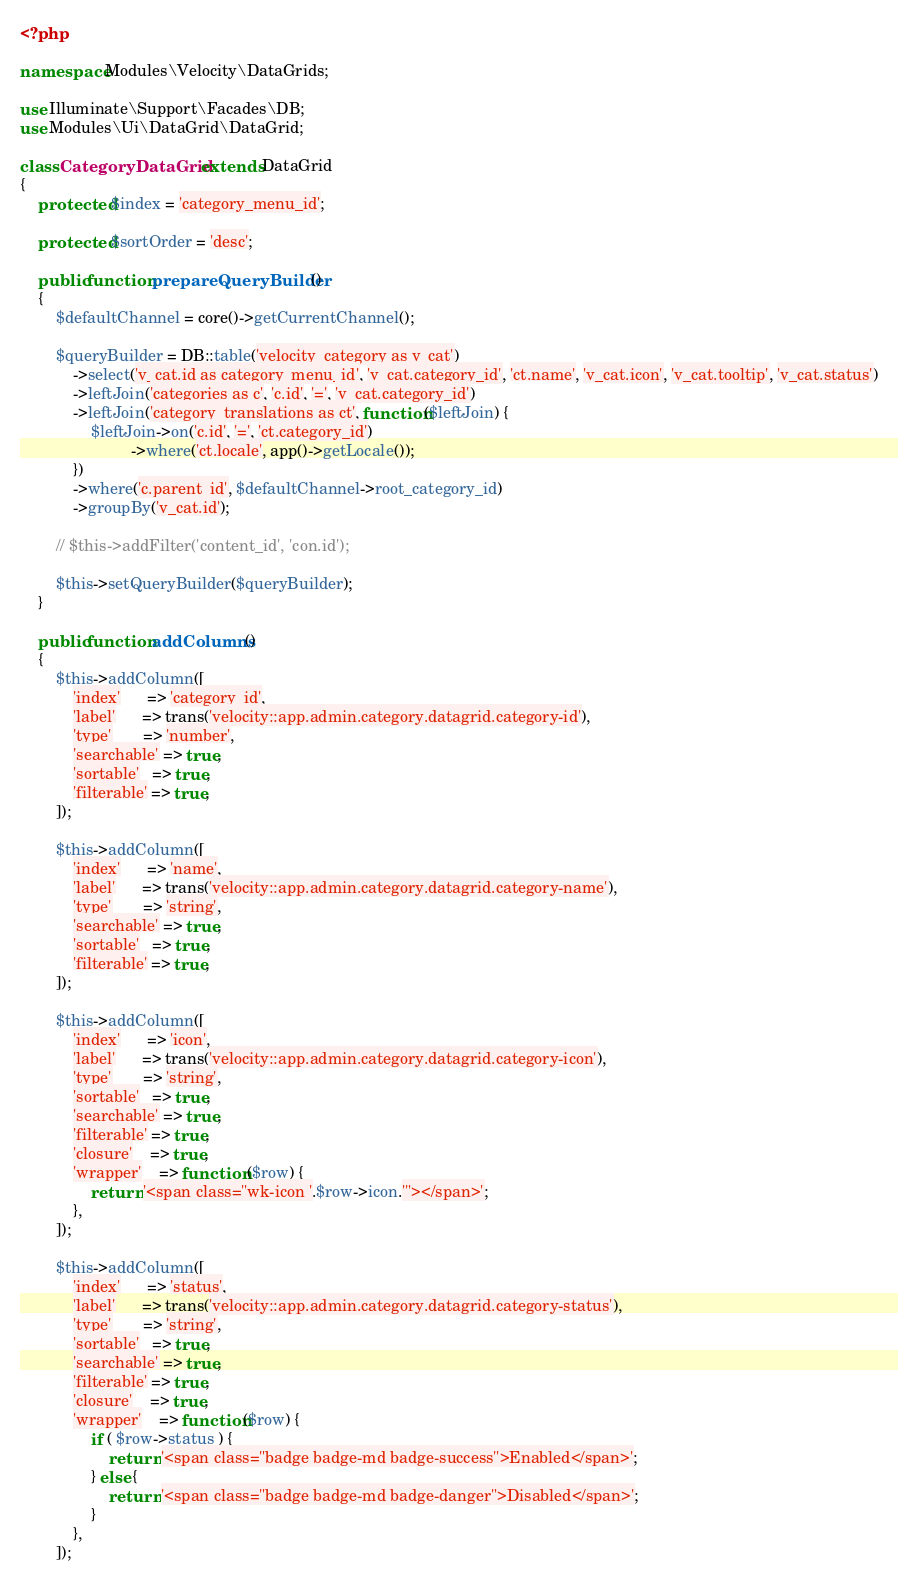Convert code to text. <code><loc_0><loc_0><loc_500><loc_500><_PHP_><?php

namespace Modules\Velocity\DataGrids;

use Illuminate\Support\Facades\DB;
use Modules\Ui\DataGrid\DataGrid;

class CategoryDataGrid extends DataGrid
{
    protected $index = 'category_menu_id';

    protected $sortOrder = 'desc';

    public function prepareQueryBuilder()
    {
        $defaultChannel = core()->getCurrentChannel();

        $queryBuilder = DB::table('velocity_category as v_cat')
            ->select('v_cat.id as category_menu_id', 'v_cat.category_id', 'ct.name', 'v_cat.icon', 'v_cat.tooltip', 'v_cat.status')
            ->leftJoin('categories as c', 'c.id', '=', 'v_cat.category_id')
            ->leftJoin('category_translations as ct', function($leftJoin) {
                $leftJoin->on('c.id', '=', 'ct.category_id')
                         ->where('ct.locale', app()->getLocale());
            })
            ->where('c.parent_id', $defaultChannel->root_category_id)
            ->groupBy('v_cat.id');

        // $this->addFilter('content_id', 'con.id');

        $this->setQueryBuilder($queryBuilder);
    }

    public function addColumns()
    {
        $this->addColumn([
            'index'      => 'category_id',
            'label'      => trans('velocity::app.admin.category.datagrid.category-id'),
            'type'       => 'number',
            'searchable' => true,
            'sortable'   => true,
            'filterable' => true,
        ]);

        $this->addColumn([
            'index'      => 'name',
            'label'      => trans('velocity::app.admin.category.datagrid.category-name'),
            'type'       => 'string',
            'searchable' => true,
            'sortable'   => true,
            'filterable' => true,
        ]);

        $this->addColumn([
            'index'      => 'icon',
            'label'      => trans('velocity::app.admin.category.datagrid.category-icon'),
            'type'       => 'string',
            'sortable'   => true,
            'searchable' => true,
            'filterable' => true,
            'closure'    => true,
            'wrapper'    => function ($row) {
                return '<span class="wk-icon '.$row->icon.'"></span>';
            },
        ]);

        $this->addColumn([
            'index'      => 'status',
            'label'      => trans('velocity::app.admin.category.datagrid.category-status'),
            'type'       => 'string',
            'sortable'   => true,
            'searchable' => true,
            'filterable' => true,
            'closure'    => true,
            'wrapper'    => function($row) {
                if ( $row->status ) {
                    return '<span class="badge badge-md badge-success">Enabled</span>';
                } else {
                    return '<span class="badge badge-md badge-danger">Disabled</span>';
                }
            },
        ]);</code> 